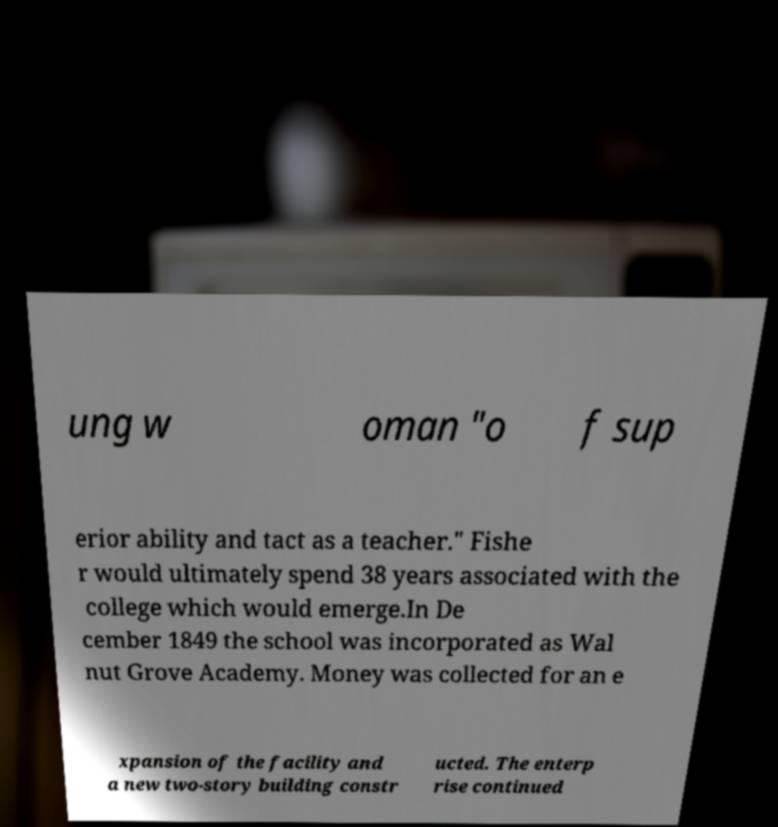Can you accurately transcribe the text from the provided image for me? ung w oman "o f sup erior ability and tact as a teacher." Fishe r would ultimately spend 38 years associated with the college which would emerge.In De cember 1849 the school was incorporated as Wal nut Grove Academy. Money was collected for an e xpansion of the facility and a new two-story building constr ucted. The enterp rise continued 